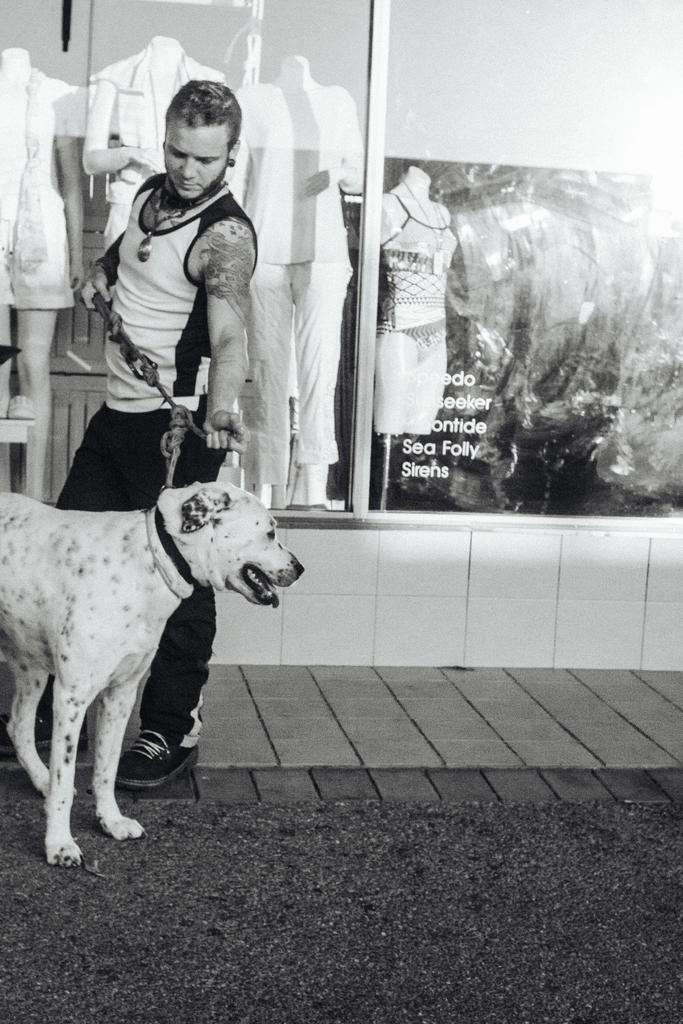What is the color scheme of the image? The image is black and white. Who is present in the image? There is a man in the image. What is the man holding in the image? The man is holding a dog's belt. What can be seen in the background of the image? There are mannequins and clothes in the background of the image. What type of soap is the man using to wash the dog in the image? There is no soap or dog present in the image; the man is holding a dog's belt. 